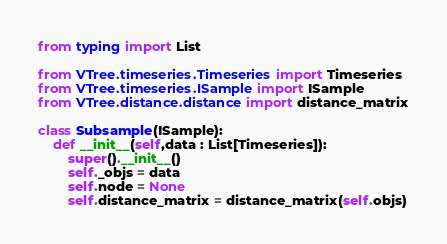Convert code to text. <code><loc_0><loc_0><loc_500><loc_500><_Python_>from typing import List

from VTree.timeseries.Timeseries import Timeseries
from VTree.timeseries.ISample import ISample
from VTree.distance.distance import distance_matrix

class Subsample(ISample):
    def __init__(self,data : List[Timeseries]):
        super().__init__()
        self._objs = data
        self.node = None
        self.distance_matrix = distance_matrix(self.objs)</code> 